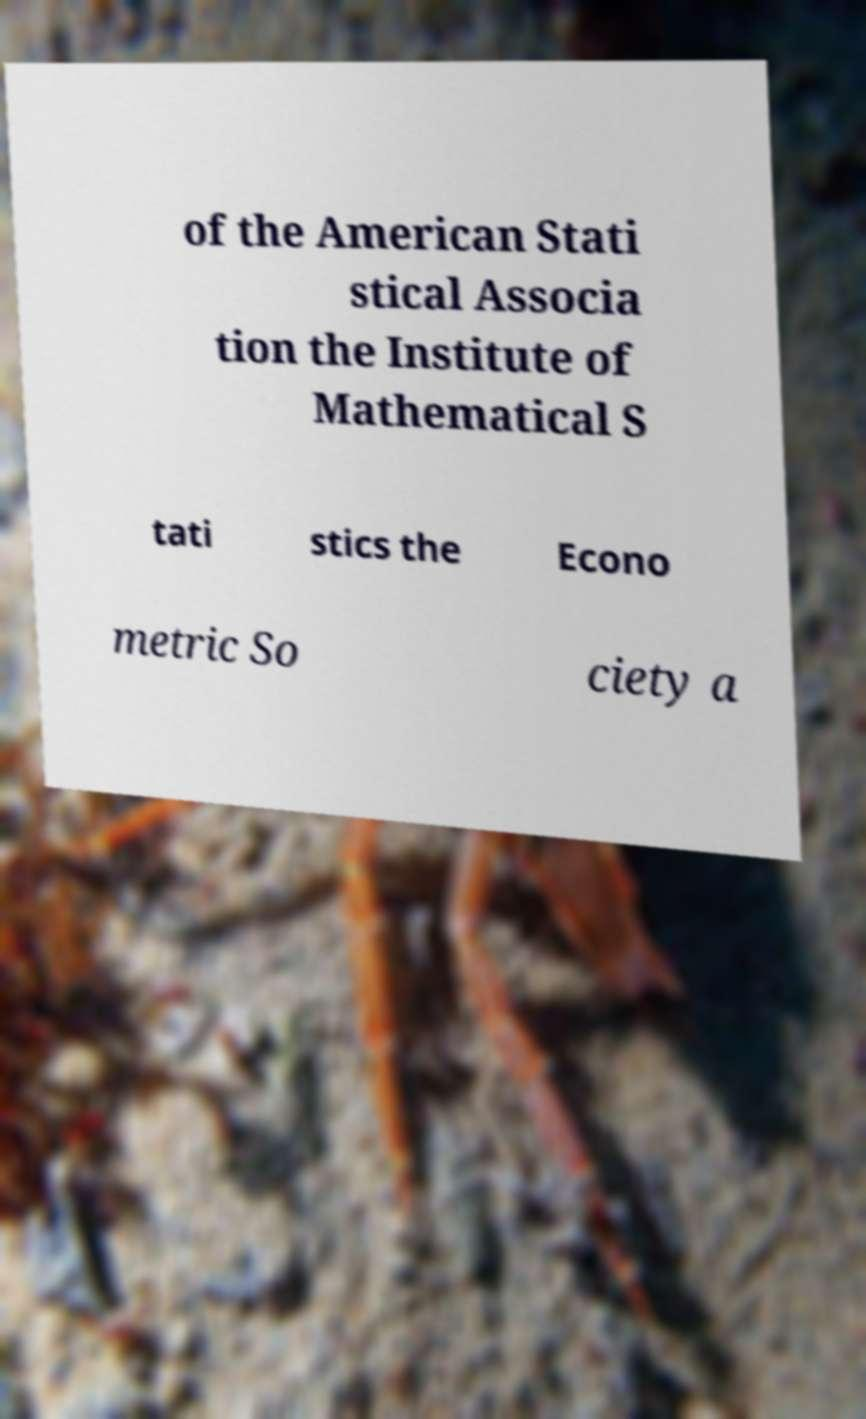What messages or text are displayed in this image? I need them in a readable, typed format. of the American Stati stical Associa tion the Institute of Mathematical S tati stics the Econo metric So ciety a 